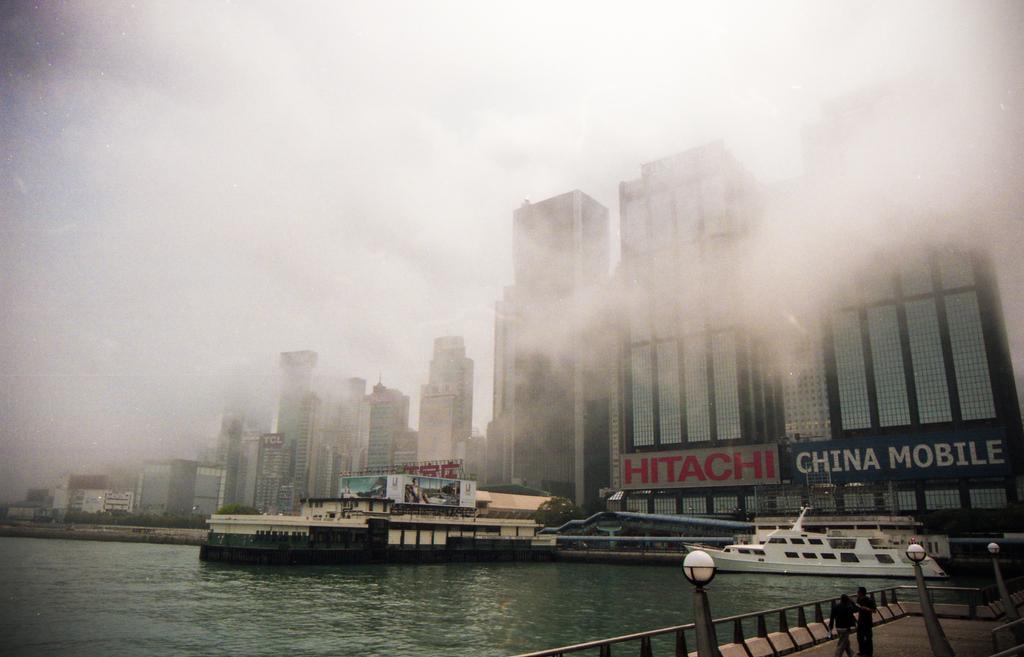Please provide a concise description of this image. In this picture we can see a few boats in water. There are few buildings. We can see some street lights and two people on the path. 